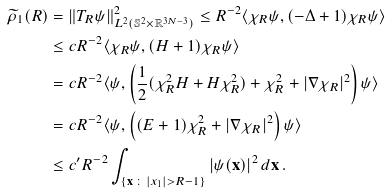<formula> <loc_0><loc_0><loc_500><loc_500>\widetilde { \rho } _ { 1 } ( R ) & = \| T _ { R } \psi \| _ { L ^ { 2 } ( \mathbb { S } ^ { 2 } \times { \mathbb { R } } ^ { 3 N - 3 } ) } ^ { 2 } \leq R ^ { - 2 } \langle \chi _ { R } \psi , ( - \Delta + 1 ) \chi _ { R } \psi \rangle \\ & \leq c R ^ { - 2 } \langle \chi _ { R } \psi , ( H + 1 ) \chi _ { R } \psi \rangle \\ & = c R ^ { - 2 } \langle \psi , \left ( \frac { 1 } { 2 } ( \chi _ { R } ^ { 2 } H + H \chi _ { R } ^ { 2 } ) + \chi _ { R } ^ { 2 } + | \nabla \chi _ { R } | ^ { 2 } \right ) \psi \rangle \\ & = c R ^ { - 2 } \langle \psi , \left ( ( E + 1 ) \chi _ { R } ^ { 2 } + | \nabla \chi _ { R } | ^ { 2 } \right ) \psi \rangle \\ & \leq c ^ { \prime } R ^ { - 2 } \int _ { \{ { \mathbf x } \, \colon \, | x _ { 1 } | > R - 1 \} } | \psi ( { \mathbf x } ) | ^ { 2 } \, d { \mathbf x } \, .</formula> 